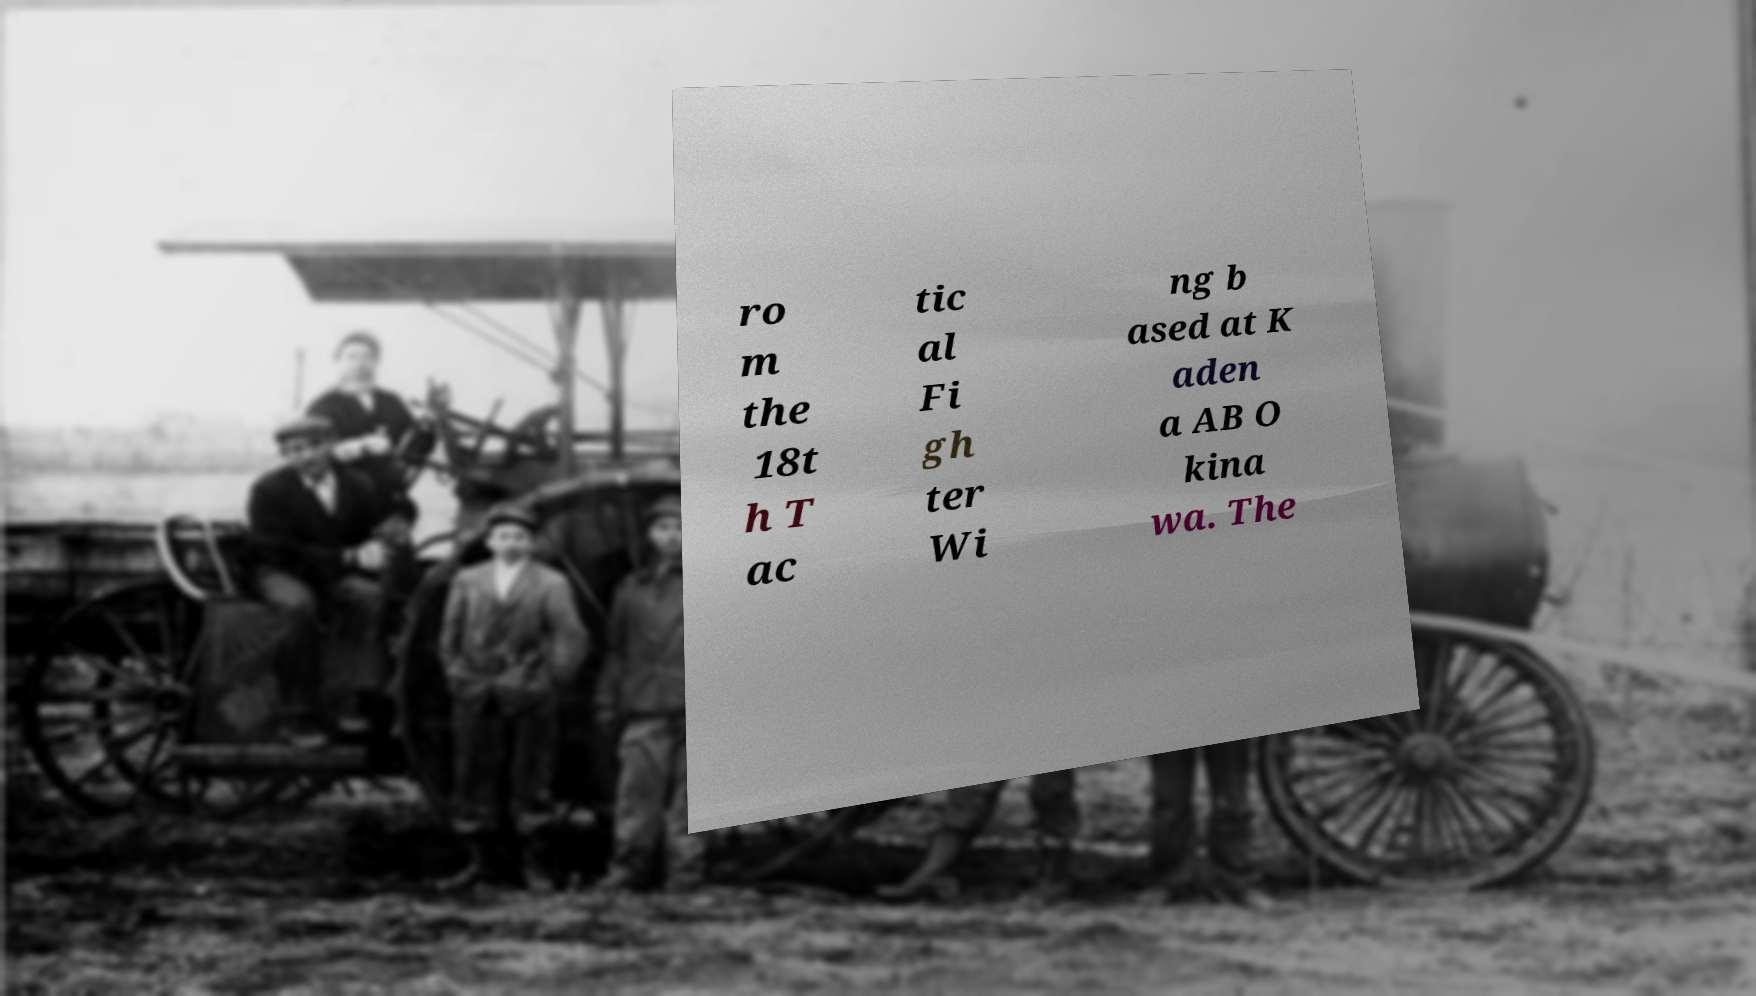Please identify and transcribe the text found in this image. ro m the 18t h T ac tic al Fi gh ter Wi ng b ased at K aden a AB O kina wa. The 